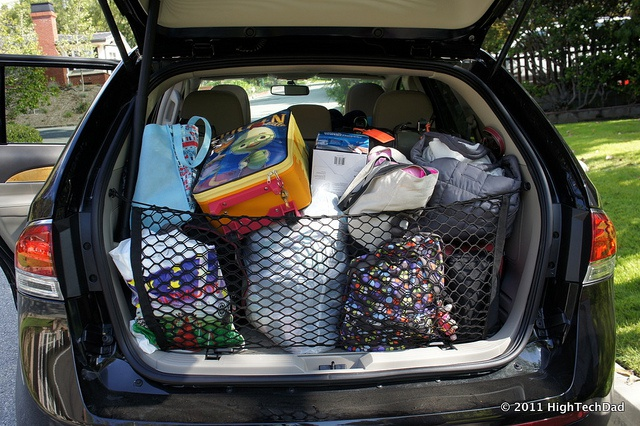Describe the objects in this image and their specific colors. I can see car in black, ivory, gray, darkgray, and lightgray tones, suitcase in ivory, black, red, gray, and brown tones, handbag in ivory, black, gray, navy, and darkgray tones, handbag in ivory, darkgray, gray, lightgray, and black tones, and handbag in ivory, gray, lightblue, and black tones in this image. 